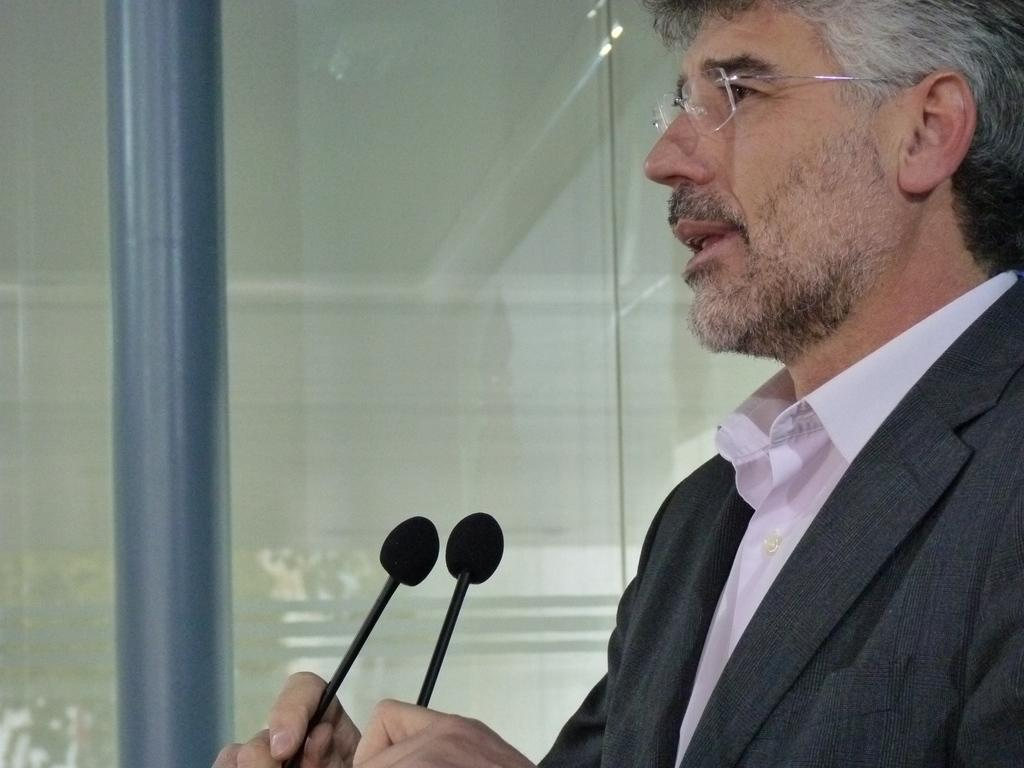What is the main subject of the image? There is a person in the image. What is the person holding in the image? The person is holding a microphone. How many friends are visible in the image? There is no mention of friends in the image; only a person holding a microphone is present. What type of bucket can be seen in the image? There is no bucket present in the image. 